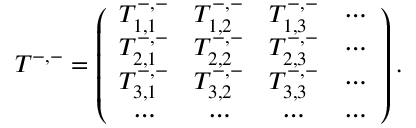<formula> <loc_0><loc_0><loc_500><loc_500>T ^ { - , - } = \left ( \begin{array} { c c c c c } { T _ { 1 , 1 } ^ { - , - } } & { T _ { 1 , 2 } ^ { - , - } } & { T _ { 1 , 3 } ^ { - , - } } & { \cdots } \\ { T _ { 2 , 1 } ^ { - , - } } & { T _ { 2 , 2 } ^ { - , - } } & { T _ { 2 , 3 } ^ { - , - } } & { \cdots } \\ { T _ { 3 , 1 } ^ { - , - } } & { T _ { 3 , 2 } ^ { - , - } } & { T _ { 3 , 3 } ^ { - , - } } & { \cdots } \\ { \cdots } & { \cdots } & { \cdots } & { \cdots } \end{array} \right ) .</formula> 